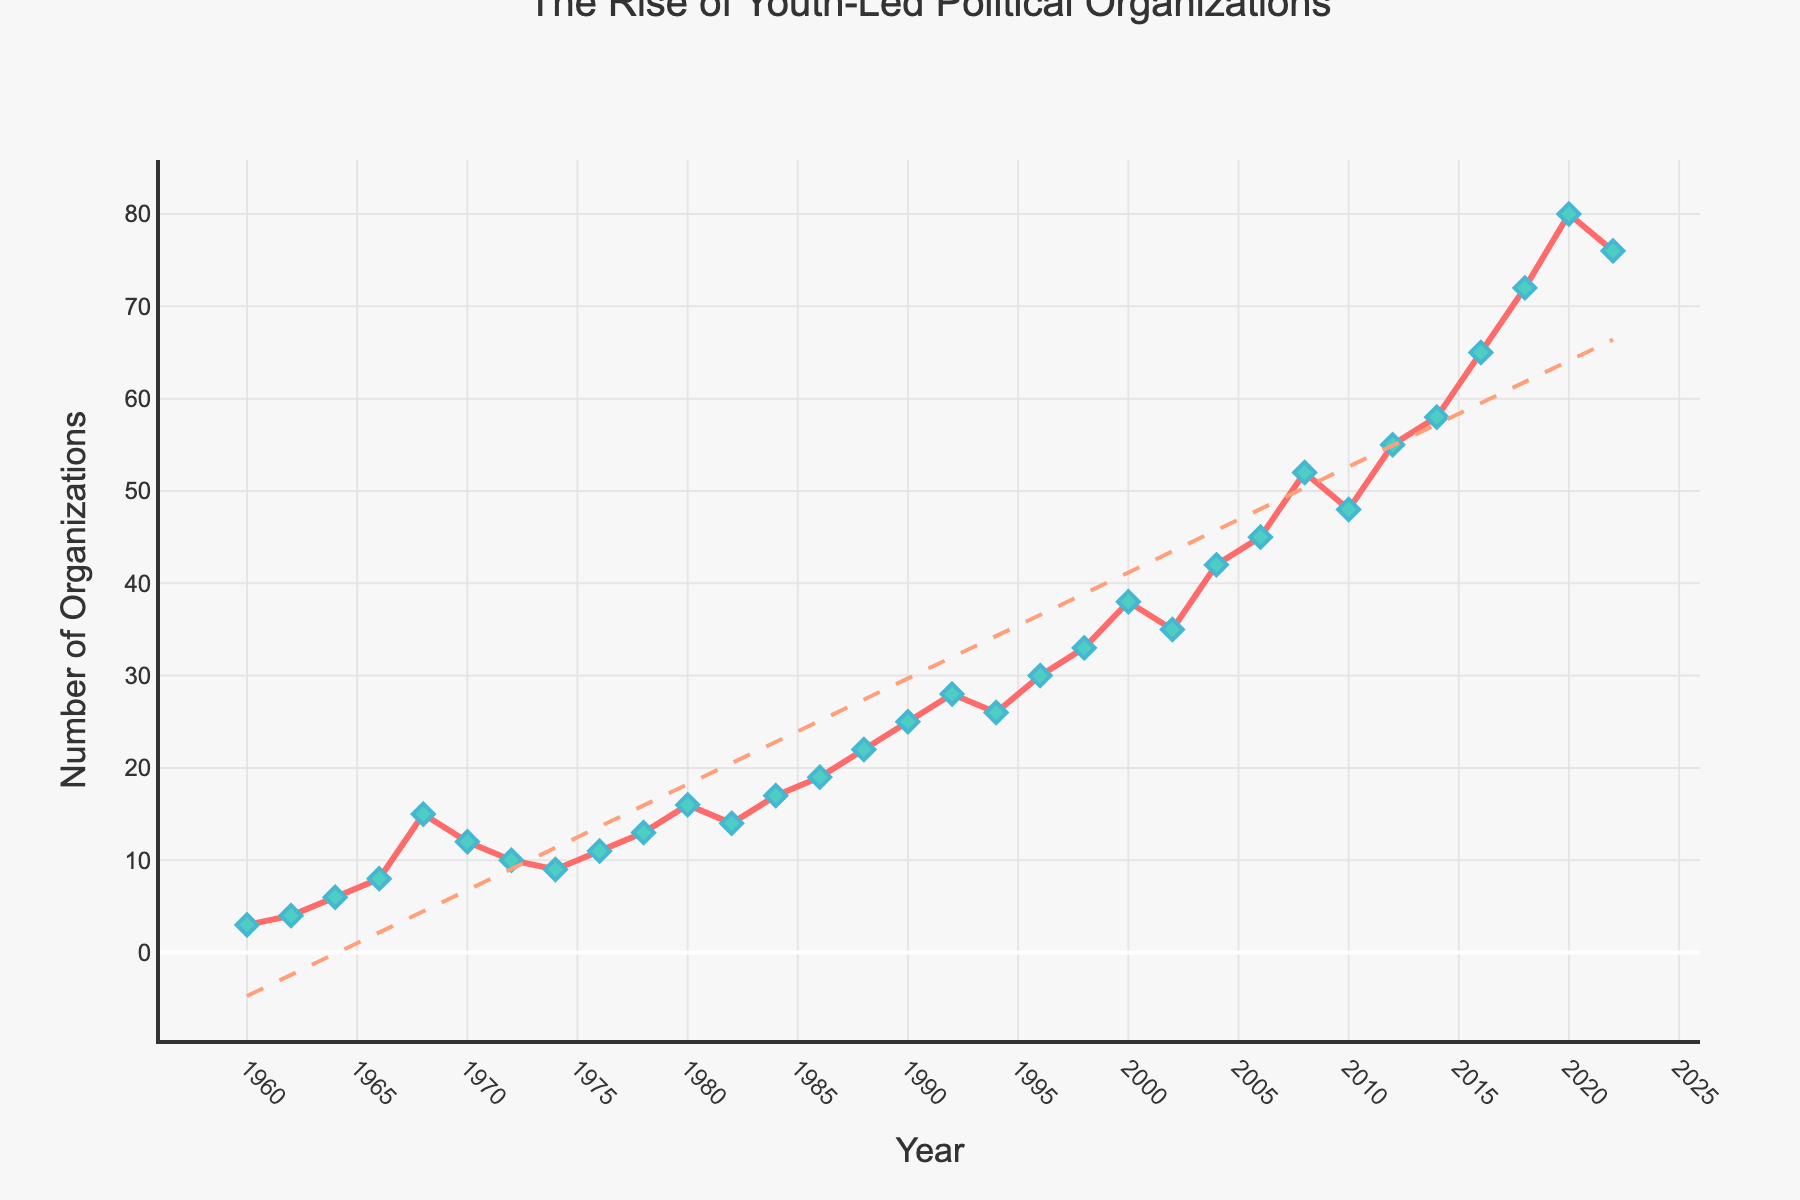How many youth-led political organizations were founded in 2020? To determine the number of organizations founded in 2020, locate the year 2020 on the x-axis and read the corresponding y-axis value.
Answer: 80 Which year had the greatest increase in the number of organizations founded compared to the previous year? To find the greatest increase, compare the difference in the number of organizations between consecutive years and identify the largest difference. From 2018 (72) to 2020 (80), the increase is 8, but from 2016 (65) to 2018 (72), the increase is 7. The greatest increase is noticed between these years.
Answer: 2016 to 2018 What is the average number of organizations founded from 1960 to 1970? Sum the numbers of organizations founded from 1960 to 1970 and divide by the number of years. (3+4+6+8+15+12+10) / 7 = 8.2857
Answer: 8.29 Did the number of organizations founded in 2022 increase or decrease compared to 2020? Compare the values for 2022 (76) and 2020 (80). Since 76 is less than 80, the number of organizations founded has decreased.
Answer: Decrease What is the trend in the number of organizations founded from 2000 to 2022? Observe the overall direction of the line between 2000 and 2022. This period shows an increasing trend with fluctuations reaching a peak around 2020.
Answer: Increasing trend Identify the period with the most consistent (smallest fluctuations) growth in number of organizations founded. Identify the period where the growth line appears least volatile. The period from 2012 to 2020 shows consistent growth with few fluctuations.
Answer: 2012 to 2020 What is the overall pattern seen in the number of youth-led political organizations founded from 1960 to 2022? Look at the line trend throughout the years. It generally shows steady growth, with occasional spikes, and major growth post-2000.
Answer: Steady growth with spikes, major growth post-2000 Calculate the total number of youth-led political organizations founded by the end of 1980. Add the number of organizations founded from 1960 to 1980. (3+4+6+8+15+12+10+9+11+13+16) = 107
Answer: 107 Between which two consecutive years was the sharpest decline in the number of organizations founded? To find the sharpest decline, compare the drop in numbers between consecutive years. The sharpest decline is between 2020 (80) and 2022 (76), which is a drop of 4.
Answer: 2020 to 2022 How does the number of organizations founded in the 1960s compare to those founded in the 1980s? Sum the number of organizations in the 1960s (3+4+6+8+15+12) and compare to the sum in the 1980s (16+14+17+19+22). 1960s total: 48; 1980s total: 88. The 1980s have substantially more.
Answer: 1980s have more 